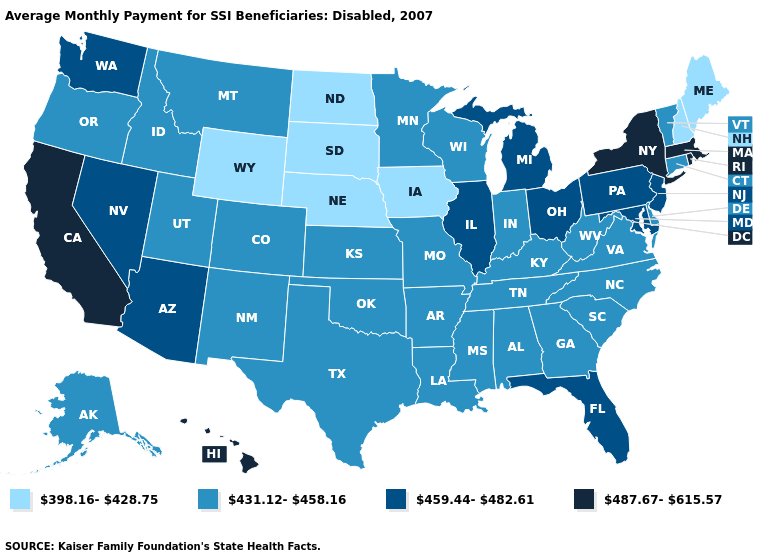What is the highest value in the USA?
Be succinct. 487.67-615.57. Does New York have the lowest value in the USA?
Be succinct. No. What is the value of Louisiana?
Quick response, please. 431.12-458.16. What is the value of South Dakota?
Write a very short answer. 398.16-428.75. What is the value of Alaska?
Give a very brief answer. 431.12-458.16. What is the value of Kentucky?
Be succinct. 431.12-458.16. What is the value of Alabama?
Keep it brief. 431.12-458.16. Among the states that border Kansas , does Nebraska have the highest value?
Write a very short answer. No. What is the value of Illinois?
Concise answer only. 459.44-482.61. What is the value of South Carolina?
Give a very brief answer. 431.12-458.16. Which states have the highest value in the USA?
Keep it brief. California, Hawaii, Massachusetts, New York, Rhode Island. Name the states that have a value in the range 431.12-458.16?
Write a very short answer. Alabama, Alaska, Arkansas, Colorado, Connecticut, Delaware, Georgia, Idaho, Indiana, Kansas, Kentucky, Louisiana, Minnesota, Mississippi, Missouri, Montana, New Mexico, North Carolina, Oklahoma, Oregon, South Carolina, Tennessee, Texas, Utah, Vermont, Virginia, West Virginia, Wisconsin. What is the lowest value in the West?
Concise answer only. 398.16-428.75. Name the states that have a value in the range 487.67-615.57?
Concise answer only. California, Hawaii, Massachusetts, New York, Rhode Island. What is the value of Mississippi?
Keep it brief. 431.12-458.16. 